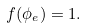Convert formula to latex. <formula><loc_0><loc_0><loc_500><loc_500>f ( \phi _ { e } ) = 1 .</formula> 